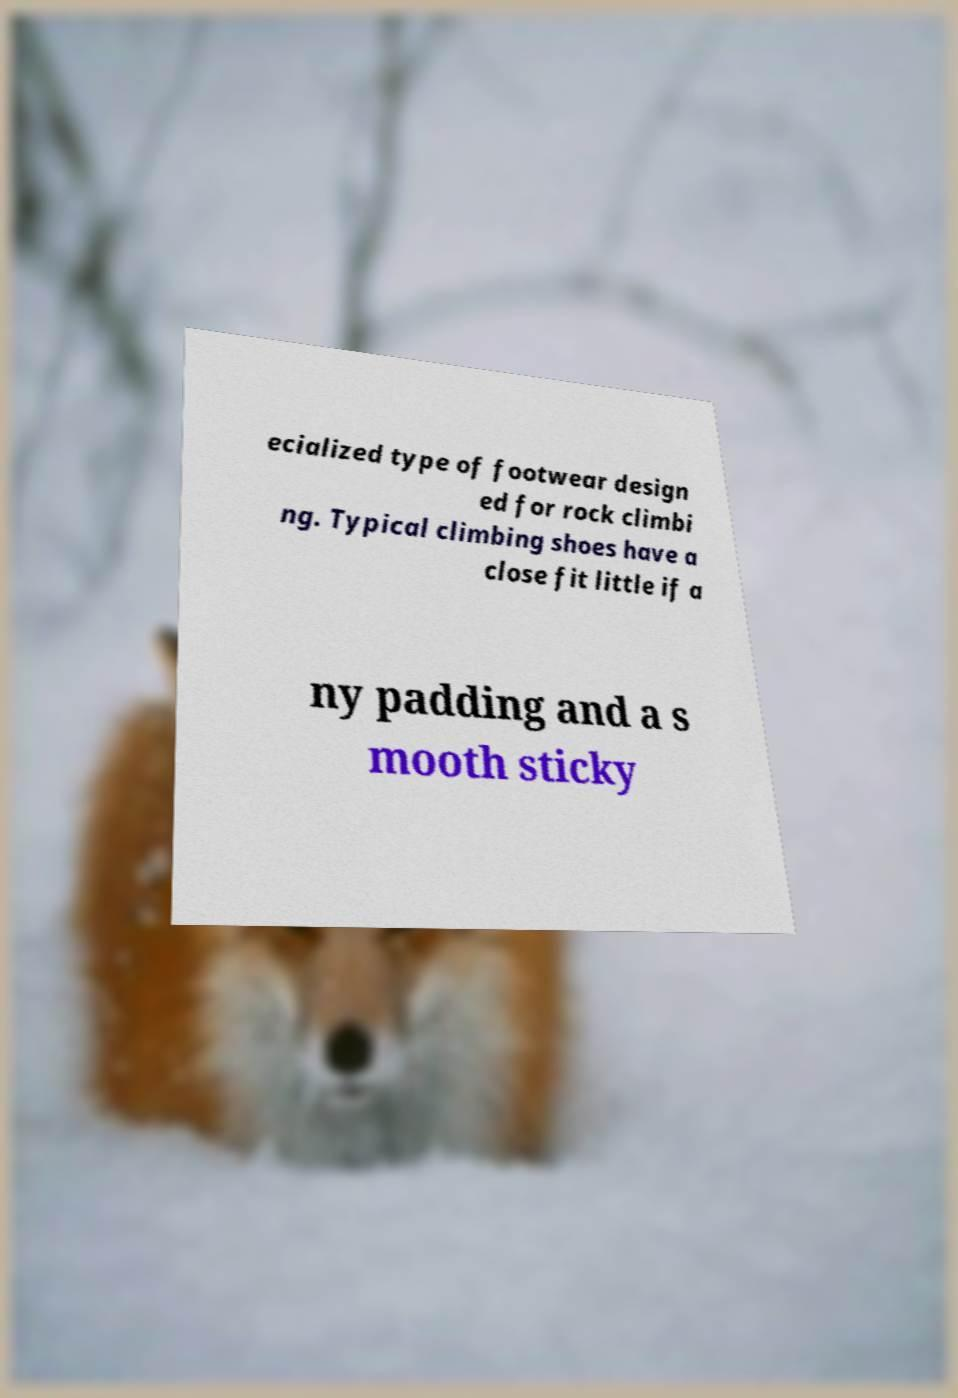Please identify and transcribe the text found in this image. ecialized type of footwear design ed for rock climbi ng. Typical climbing shoes have a close fit little if a ny padding and a s mooth sticky 